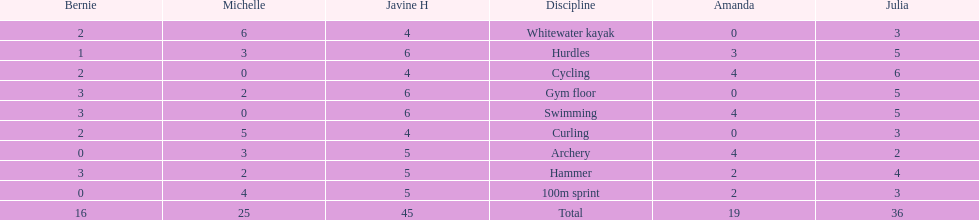What is the first discipline listed on this chart? Whitewater kayak. 